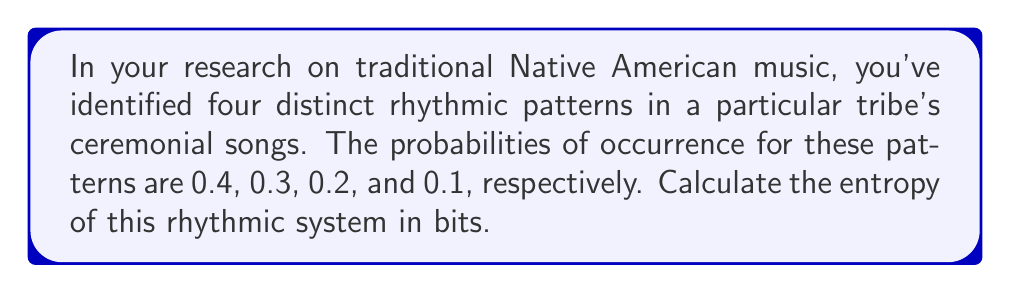Teach me how to tackle this problem. To calculate the entropy of this rhythmic system, we'll use the Shannon entropy formula:

$$H = -\sum_{i=1}^{n} p_i \log_2(p_i)$$

Where:
- $H$ is the entropy in bits
- $p_i$ is the probability of each rhythmic pattern
- $n$ is the number of distinct rhythmic patterns (in this case, 4)

Let's calculate each term:

1. For $p_1 = 0.4$:
   $-0.4 \log_2(0.4) = 0.528321$

2. For $p_2 = 0.3$:
   $-0.3 \log_2(0.3) = 0.521126$

3. For $p_3 = 0.2$:
   $-0.2 \log_2(0.2) = 0.464386$

4. For $p_4 = 0.1$:
   $-0.1 \log_2(0.1) = 0.332193$

Now, sum all these terms:

$$H = 0.528321 + 0.521126 + 0.464386 + 0.332193 = 1.846026$$

Therefore, the entropy of this rhythmic system is approximately 1.846026 bits.
Answer: 1.846026 bits 